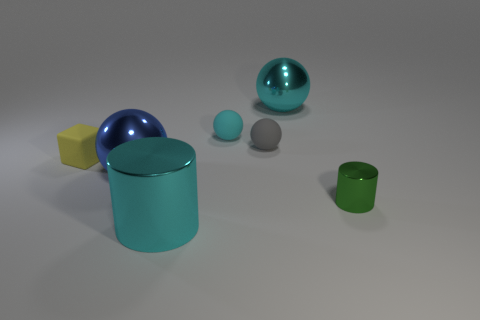Do the metal sphere behind the tiny cyan rubber object and the big metallic cylinder left of the small metallic thing have the same color?
Give a very brief answer. Yes. What is the material of the cyan object that is the same size as the yellow object?
Give a very brief answer. Rubber. Is there a small gray rubber object of the same shape as the tiny cyan matte object?
Provide a short and direct response. Yes. Is there anything else that has the same shape as the tiny yellow thing?
Give a very brief answer. No. There is a object that is to the right of the big object that is on the right side of the cyan shiny object that is in front of the blue shiny object; what is it made of?
Ensure brevity in your answer.  Metal. Are there any cylinders that have the same size as the yellow cube?
Keep it short and to the point. Yes. There is a large ball right of the sphere that is left of the large cyan metal cylinder; what color is it?
Ensure brevity in your answer.  Cyan. How many big blue metallic balls are there?
Your response must be concise. 1. Is the big metallic cylinder the same color as the tiny metallic cylinder?
Your response must be concise. No. Is the number of green things that are behind the cyan matte sphere less than the number of tiny things that are behind the small matte cube?
Ensure brevity in your answer.  Yes. 